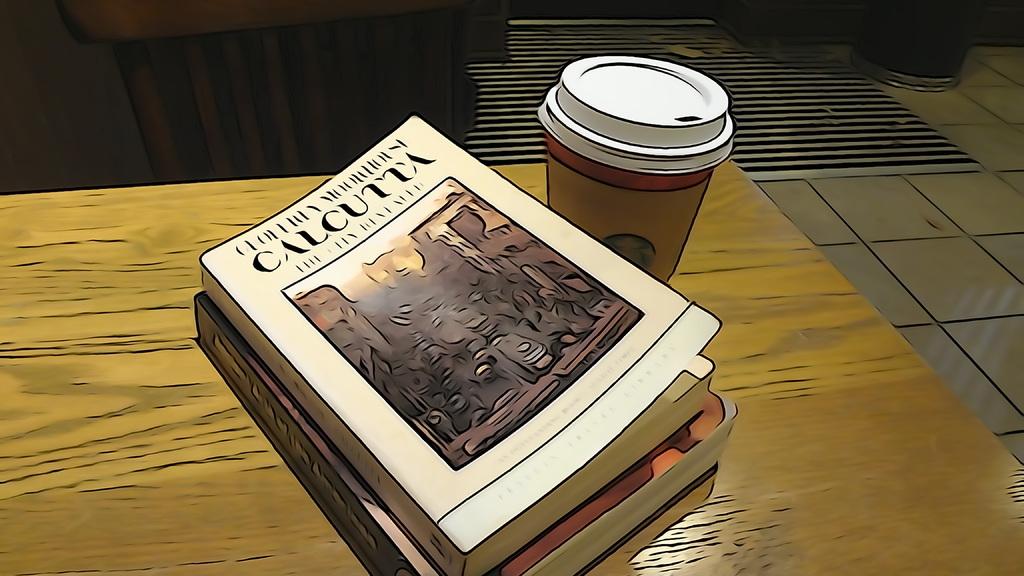What is the title of this book?
Keep it short and to the point. Calcutta. 